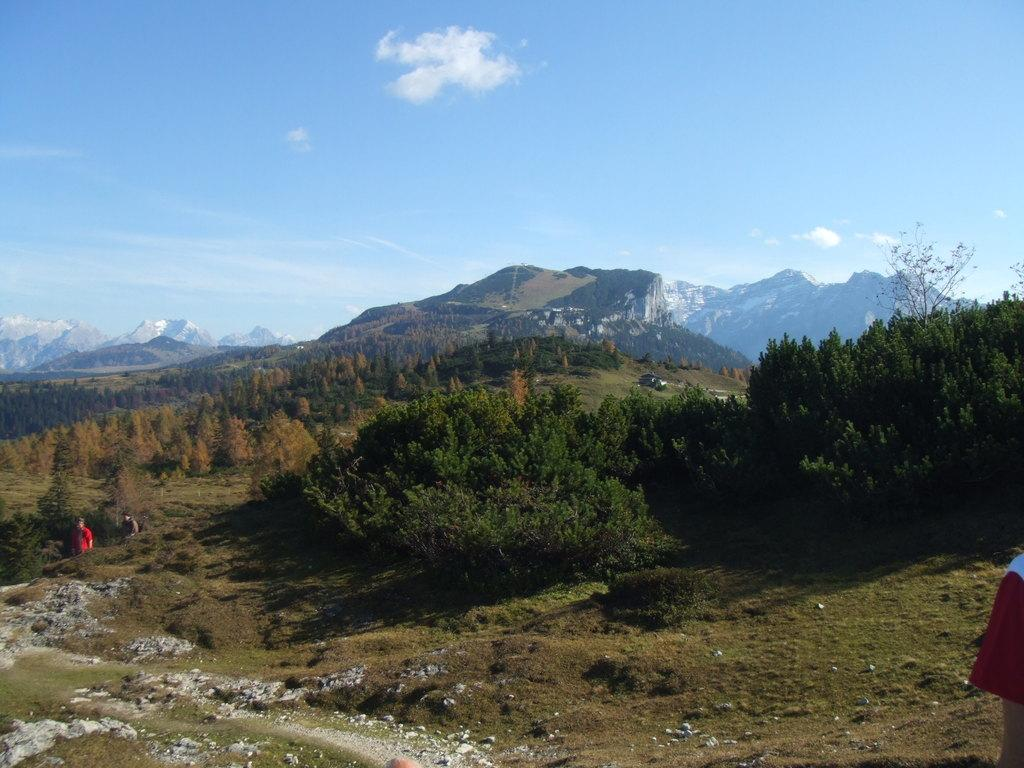How many people are in the image? There are two persons in the image. What type of natural environment is visible in the image? There are trees and grass in the image. What type of man-made object is present in the image? There is a vehicle in the image. What is visible in the background of the image? There is a mountain and sky visible in the background of the image. What is the condition of the sky in the image? The sky has clouds in it. What type of powder can be seen covering the tub in the image? There is no tub or powder present in the image. Can you describe the bee's behavior in the image? There are no bees present in the image. 